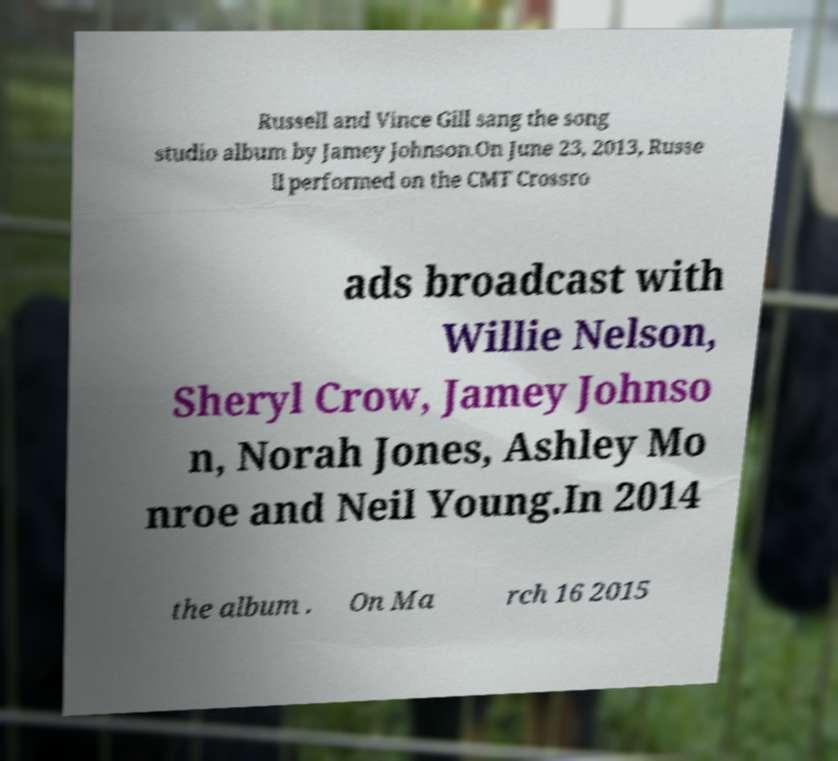Can you read and provide the text displayed in the image?This photo seems to have some interesting text. Can you extract and type it out for me? Russell and Vince Gill sang the song studio album by Jamey Johnson.On June 23, 2013, Russe ll performed on the CMT Crossro ads broadcast with Willie Nelson, Sheryl Crow, Jamey Johnso n, Norah Jones, Ashley Mo nroe and Neil Young.In 2014 the album . On Ma rch 16 2015 